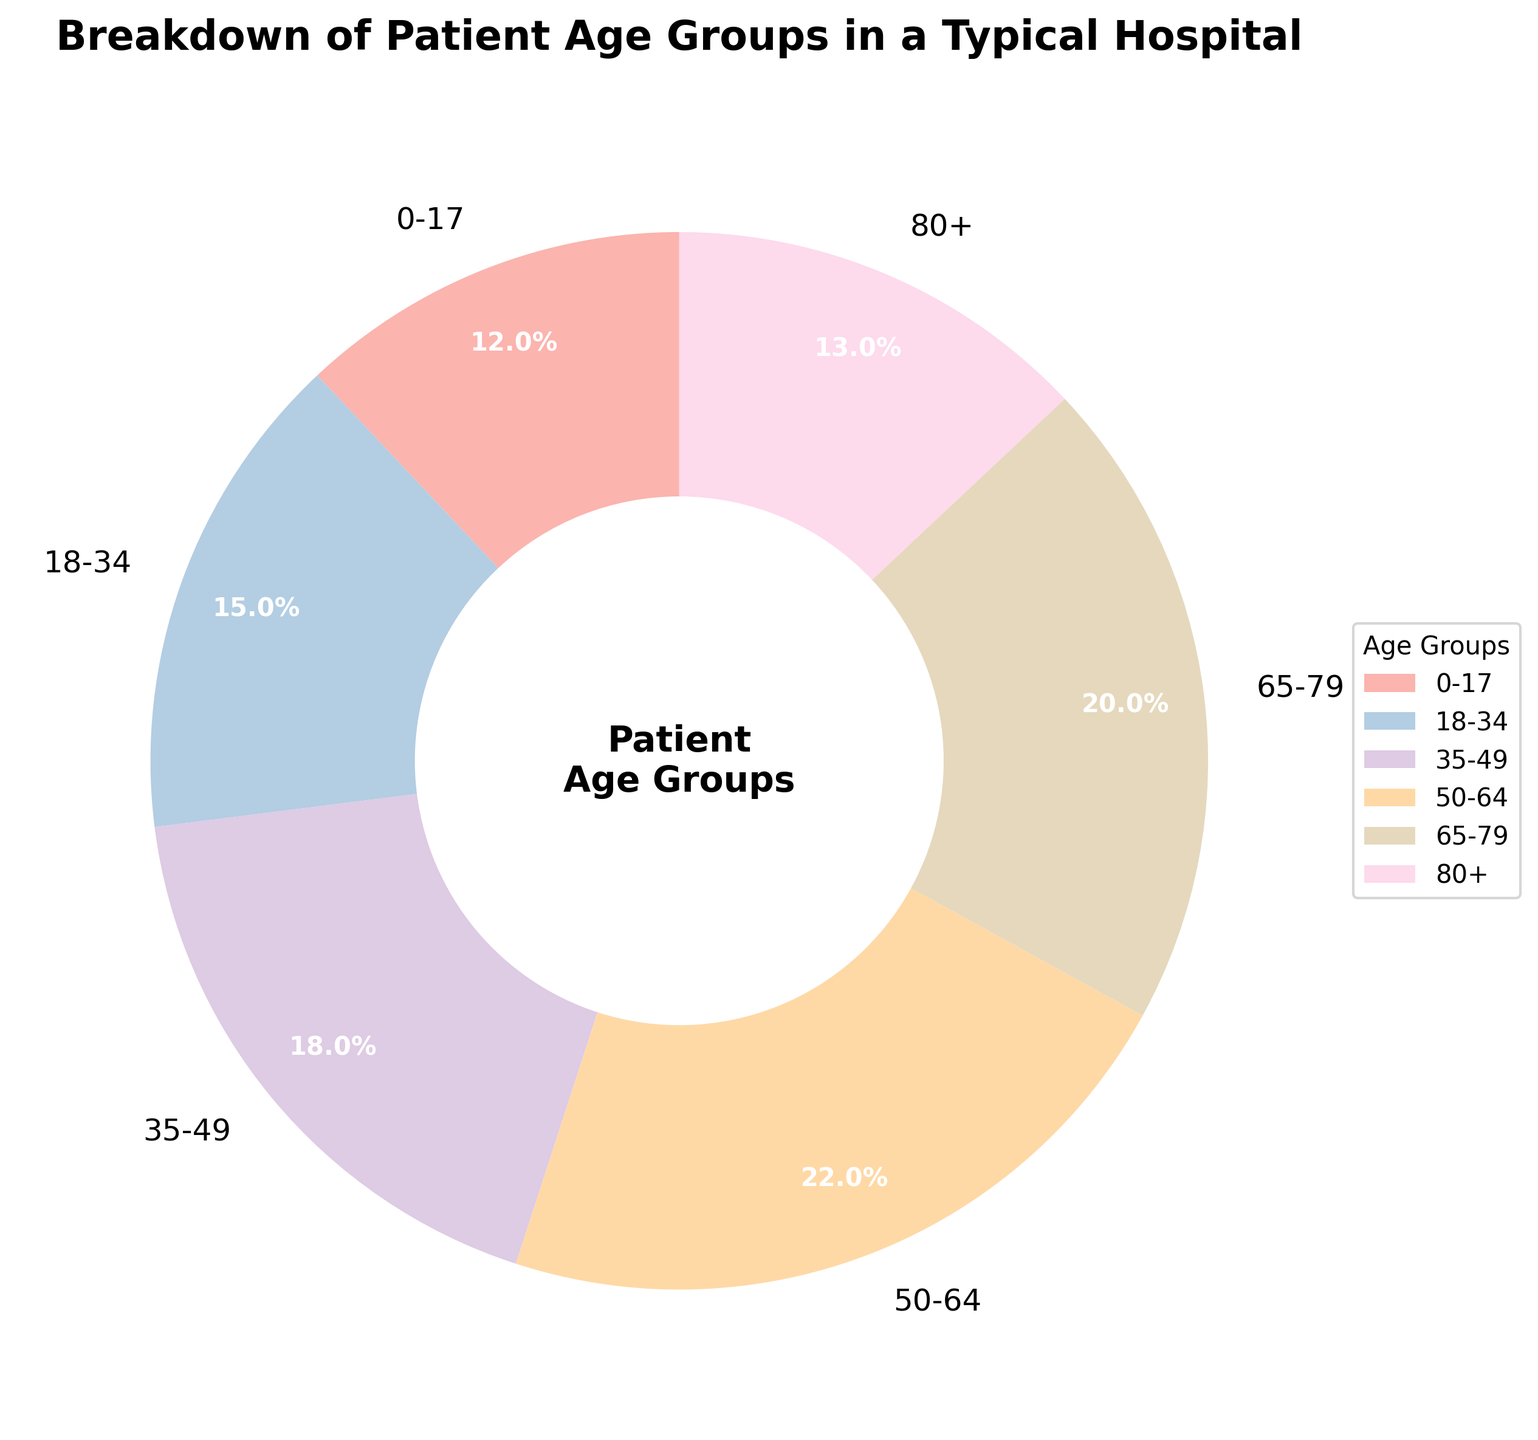What is the percentage of patients in the 50-64 age group? Look at the slice of the pie chart labeled "50-64" and note the percentage value inside or near the slice. The value is 22%.
Answer: 22% Which age group has the largest percentage of patients? Refer to the individual slices of the pie chart; the slice with the largest percentage value represents the age group with the largest percentage of patients. The "50-64" age group has the largest slice at 22%.
Answer: 50-64 How many age groups have a patient percentage of 20% or more? Observe each slice of the pie chart and note the percentage values. Count the age groups with percentages equal to or greater than 20%. The age groups "50-64" (22%) and "65-79" (20%) meet the criteria.
Answer: 2 What is the total percentage of patients in the age groups above 50? Identify the age groups above 50: "50-64", "65-79", and "80+". Sum their percentages: 22% (50-64) + 20% (65-79) + 13% (80+). The total is 55%.
Answer: 55% What is the difference in percentage between the age groups 0-17 and 80+? Find the percentage values of the age groups "0-17" and "80+" from the pie chart. Subtract the smaller percentage from the larger: 13% (80+) - 12% (0-17) = 1%.
Answer: 1% Which age group has a smaller percentage of patients, 18-34 or 35-49? Compare the percentage values of the "18-34" and "35-49" age groups on the pie chart. "18-34" has 15% while "35-49" has 18%.
Answer: 18-34 What is the total percentage of patients in the age groups below 35? Identify the age groups below 35: "0-17" and "18-34". Sum their percentages: 12% (0-17) + 15% (18-34). The total is 27%.
Answer: 27% Which age group is represented by the lightest color in the pie chart? Look at the visual attributes of the pie chart. The lightest color visually represents the youngest age group "0-17".
Answer: 0-17 